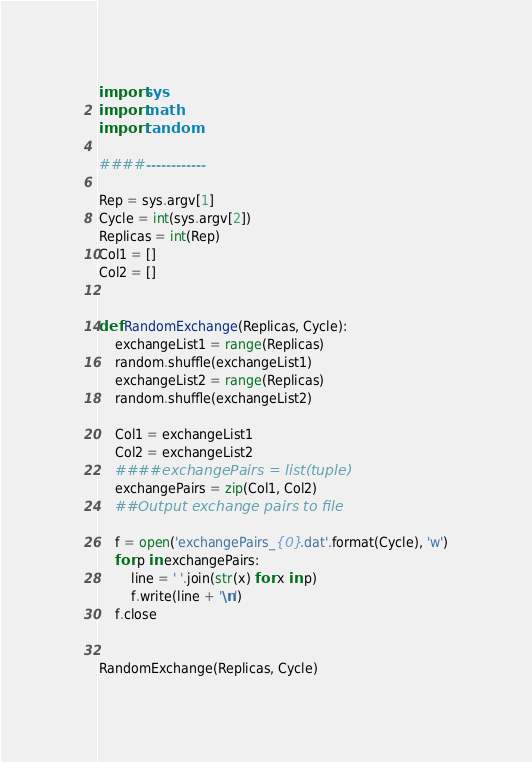<code> <loc_0><loc_0><loc_500><loc_500><_Python_>import sys
import math
import random

####------------

Rep = sys.argv[1]
Cycle = int(sys.argv[2])
Replicas = int(Rep)
Col1 = []
Col2 = []


def RandomExchange(Replicas, Cycle):
    exchangeList1 = range(Replicas)
    random.shuffle(exchangeList1)
    exchangeList2 = range(Replicas)
    random.shuffle(exchangeList2)

    Col1 = exchangeList1
    Col2 = exchangeList2
    ####exchangePairs = list(tuple)
    exchangePairs = zip(Col1, Col2)
    ##Output exchange pairs to file

    f = open('exchangePairs_{0}.dat'.format(Cycle), 'w')
    for p in exchangePairs:
        line = ' '.join(str(x) for x in p)
        f.write(line + '\n')
    f.close


RandomExchange(Replicas, Cycle)
</code> 